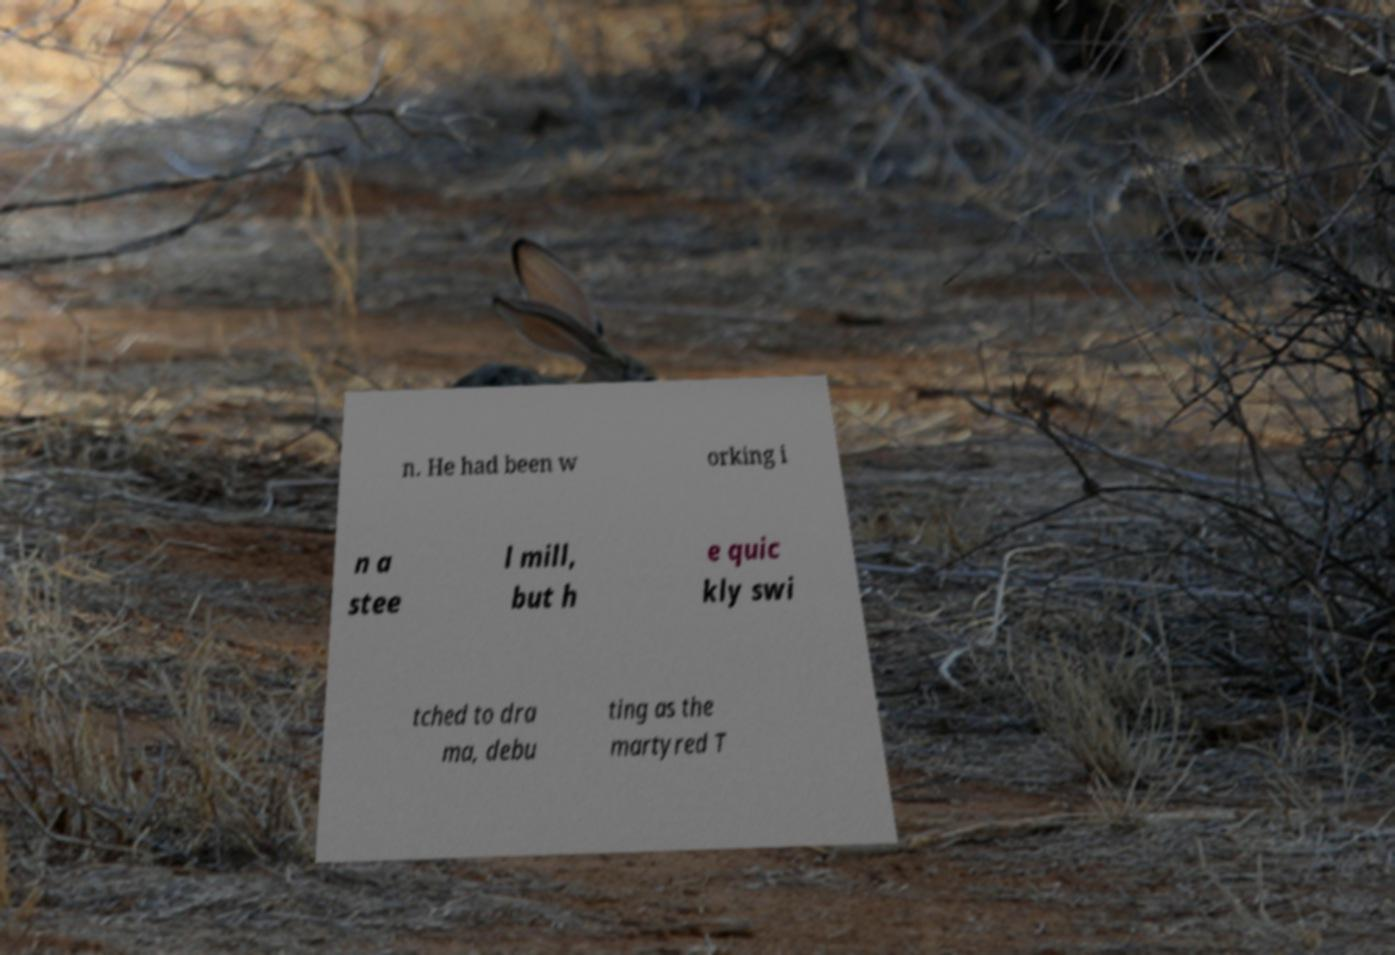Can you read and provide the text displayed in the image?This photo seems to have some interesting text. Can you extract and type it out for me? n. He had been w orking i n a stee l mill, but h e quic kly swi tched to dra ma, debu ting as the martyred T 